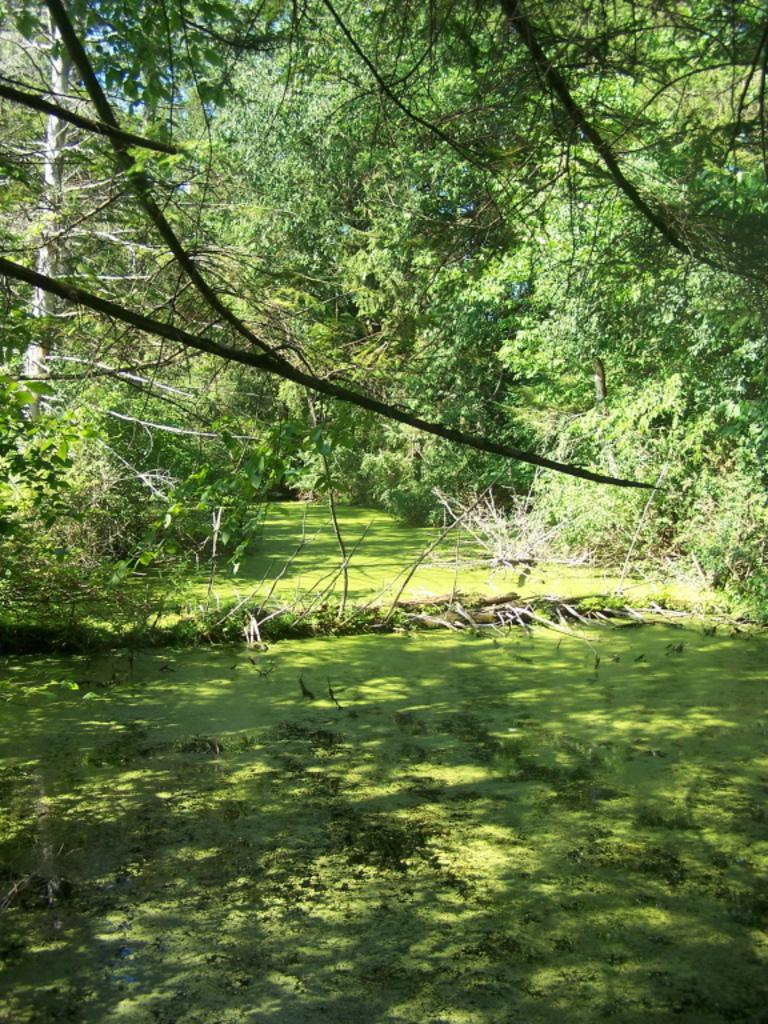What type of vegetation is at the bottom of the image? There is grass at the bottom of the image. What can be seen in the background of the image? There are trees and the sky visible in the background of the image. What type of paste can be seen on the trees in the image? There is no paste present on the trees in the image. How many people are jumping in the image? There are no people visible in the image, so it is not possible to determine how many might be jumping. 